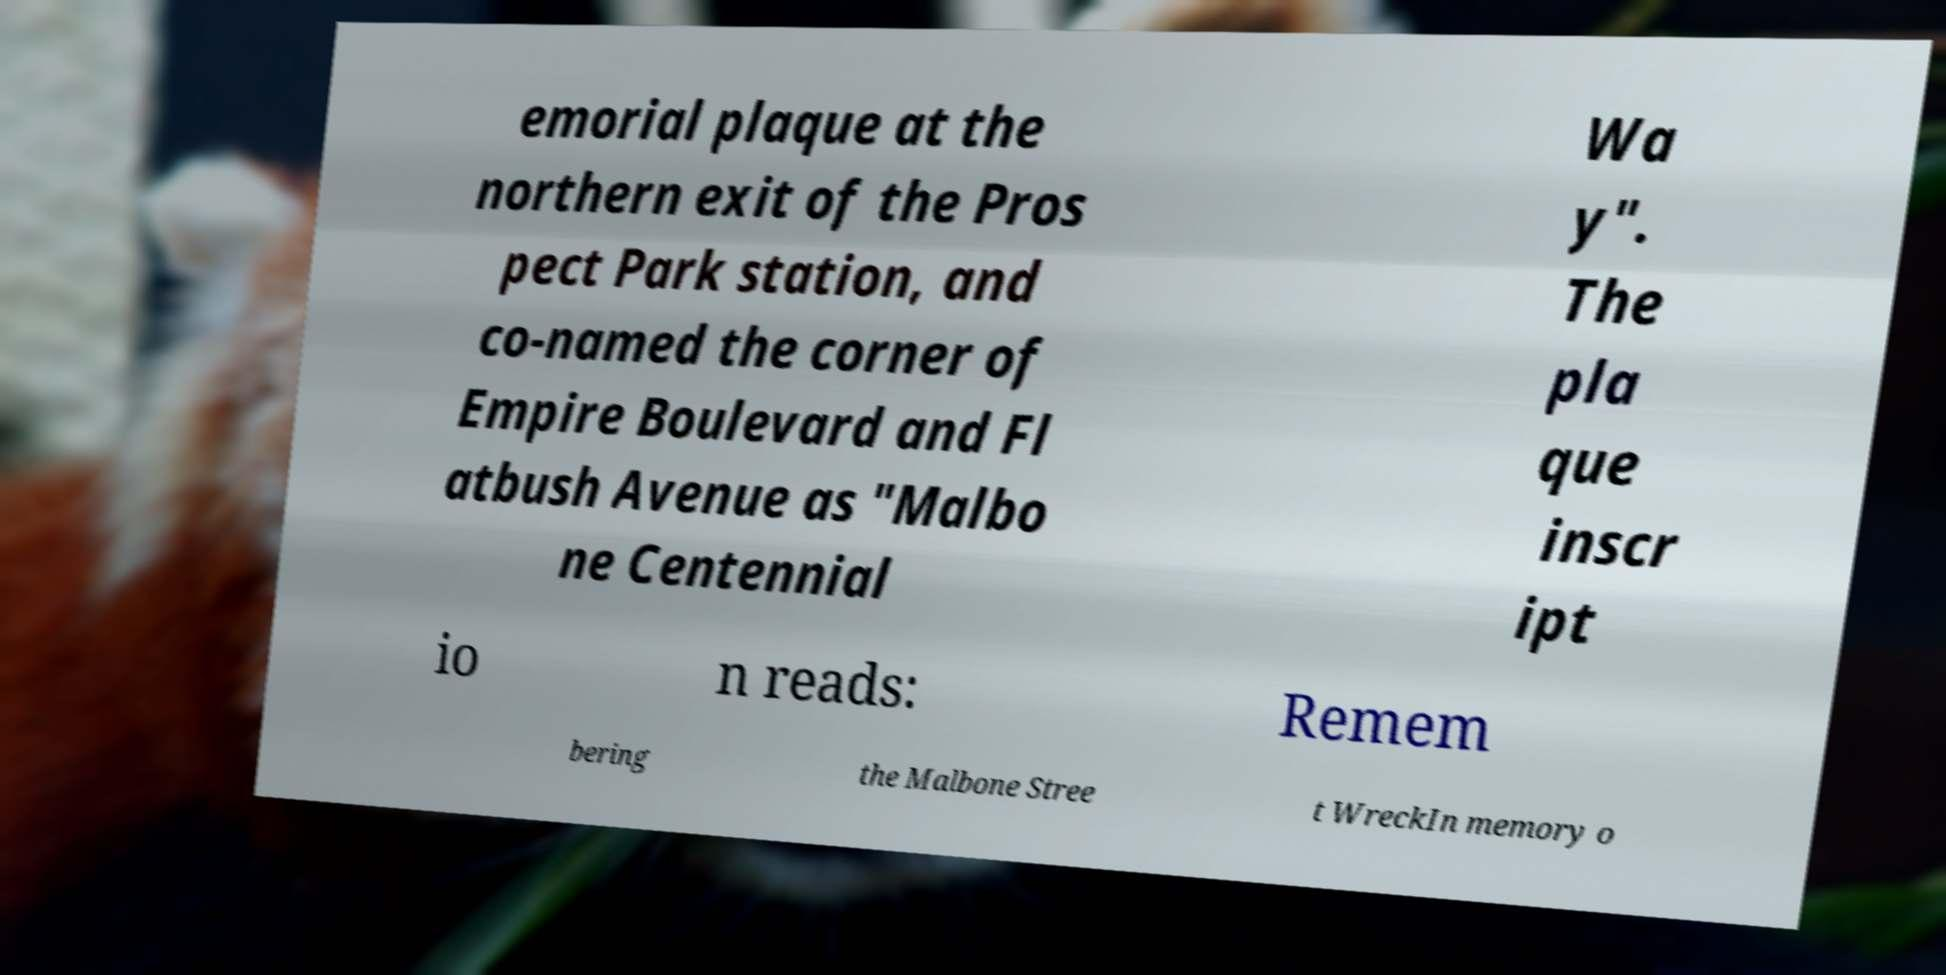There's text embedded in this image that I need extracted. Can you transcribe it verbatim? emorial plaque at the northern exit of the Pros pect Park station, and co-named the corner of Empire Boulevard and Fl atbush Avenue as "Malbo ne Centennial Wa y". The pla que inscr ipt io n reads: Remem bering the Malbone Stree t WreckIn memory o 